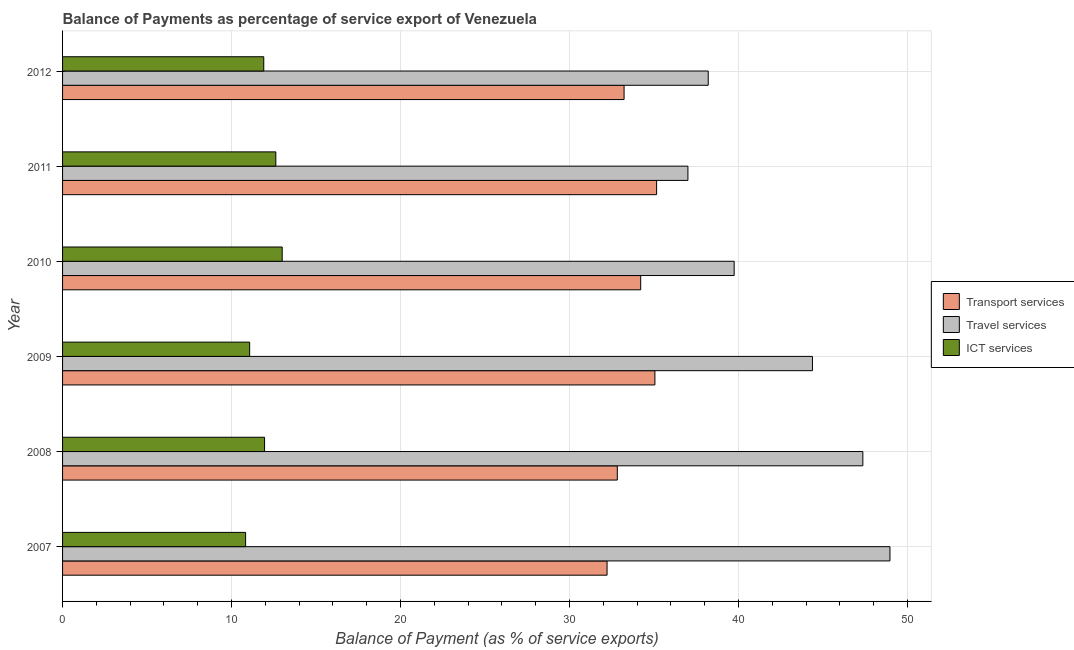How many different coloured bars are there?
Provide a succinct answer. 3. How many groups of bars are there?
Provide a short and direct response. 6. How many bars are there on the 3rd tick from the top?
Ensure brevity in your answer.  3. What is the balance of payment of transport services in 2010?
Provide a succinct answer. 34.21. Across all years, what is the maximum balance of payment of transport services?
Give a very brief answer. 35.15. Across all years, what is the minimum balance of payment of travel services?
Keep it short and to the point. 37.01. In which year was the balance of payment of ict services maximum?
Offer a terse response. 2010. In which year was the balance of payment of ict services minimum?
Ensure brevity in your answer.  2007. What is the total balance of payment of ict services in the graph?
Your answer should be compact. 71.38. What is the difference between the balance of payment of travel services in 2009 and that in 2010?
Ensure brevity in your answer.  4.63. What is the difference between the balance of payment of transport services in 2011 and the balance of payment of ict services in 2012?
Provide a succinct answer. 23.25. What is the average balance of payment of transport services per year?
Make the answer very short. 33.78. In the year 2011, what is the difference between the balance of payment of travel services and balance of payment of ict services?
Provide a succinct answer. 24.39. In how many years, is the balance of payment of transport services greater than 42 %?
Ensure brevity in your answer.  0. What is the ratio of the balance of payment of ict services in 2010 to that in 2012?
Offer a very short reply. 1.09. Is the balance of payment of transport services in 2008 less than that in 2012?
Ensure brevity in your answer.  Yes. What is the difference between the highest and the second highest balance of payment of transport services?
Make the answer very short. 0.1. What is the difference between the highest and the lowest balance of payment of travel services?
Your answer should be compact. 11.96. What does the 2nd bar from the top in 2009 represents?
Provide a short and direct response. Travel services. What does the 2nd bar from the bottom in 2012 represents?
Give a very brief answer. Travel services. Is it the case that in every year, the sum of the balance of payment of transport services and balance of payment of travel services is greater than the balance of payment of ict services?
Your answer should be very brief. Yes. How many bars are there?
Your answer should be very brief. 18. How many years are there in the graph?
Your answer should be compact. 6. What is the difference between two consecutive major ticks on the X-axis?
Ensure brevity in your answer.  10. Are the values on the major ticks of X-axis written in scientific E-notation?
Provide a short and direct response. No. Does the graph contain any zero values?
Offer a very short reply. No. Does the graph contain grids?
Offer a very short reply. Yes. Where does the legend appear in the graph?
Your response must be concise. Center right. How many legend labels are there?
Keep it short and to the point. 3. What is the title of the graph?
Make the answer very short. Balance of Payments as percentage of service export of Venezuela. What is the label or title of the X-axis?
Offer a terse response. Balance of Payment (as % of service exports). What is the label or title of the Y-axis?
Your response must be concise. Year. What is the Balance of Payment (as % of service exports) in Transport services in 2007?
Make the answer very short. 32.22. What is the Balance of Payment (as % of service exports) of Travel services in 2007?
Keep it short and to the point. 48.96. What is the Balance of Payment (as % of service exports) in ICT services in 2007?
Your answer should be compact. 10.83. What is the Balance of Payment (as % of service exports) of Transport services in 2008?
Your response must be concise. 32.83. What is the Balance of Payment (as % of service exports) of Travel services in 2008?
Provide a succinct answer. 47.36. What is the Balance of Payment (as % of service exports) of ICT services in 2008?
Offer a very short reply. 11.95. What is the Balance of Payment (as % of service exports) in Transport services in 2009?
Offer a terse response. 35.05. What is the Balance of Payment (as % of service exports) of Travel services in 2009?
Your answer should be compact. 44.37. What is the Balance of Payment (as % of service exports) of ICT services in 2009?
Make the answer very short. 11.07. What is the Balance of Payment (as % of service exports) in Transport services in 2010?
Provide a succinct answer. 34.21. What is the Balance of Payment (as % of service exports) in Travel services in 2010?
Offer a terse response. 39.74. What is the Balance of Payment (as % of service exports) of ICT services in 2010?
Provide a succinct answer. 13. What is the Balance of Payment (as % of service exports) in Transport services in 2011?
Ensure brevity in your answer.  35.15. What is the Balance of Payment (as % of service exports) in Travel services in 2011?
Offer a terse response. 37.01. What is the Balance of Payment (as % of service exports) in ICT services in 2011?
Your answer should be compact. 12.62. What is the Balance of Payment (as % of service exports) in Transport services in 2012?
Provide a short and direct response. 33.23. What is the Balance of Payment (as % of service exports) of Travel services in 2012?
Offer a very short reply. 38.21. What is the Balance of Payment (as % of service exports) of ICT services in 2012?
Your answer should be very brief. 11.91. Across all years, what is the maximum Balance of Payment (as % of service exports) in Transport services?
Provide a succinct answer. 35.15. Across all years, what is the maximum Balance of Payment (as % of service exports) in Travel services?
Offer a very short reply. 48.96. Across all years, what is the maximum Balance of Payment (as % of service exports) of ICT services?
Offer a very short reply. 13. Across all years, what is the minimum Balance of Payment (as % of service exports) in Transport services?
Your answer should be very brief. 32.22. Across all years, what is the minimum Balance of Payment (as % of service exports) of Travel services?
Your response must be concise. 37.01. Across all years, what is the minimum Balance of Payment (as % of service exports) in ICT services?
Your answer should be compact. 10.83. What is the total Balance of Payment (as % of service exports) in Transport services in the graph?
Your answer should be compact. 202.69. What is the total Balance of Payment (as % of service exports) in Travel services in the graph?
Give a very brief answer. 255.65. What is the total Balance of Payment (as % of service exports) of ICT services in the graph?
Your answer should be compact. 71.38. What is the difference between the Balance of Payment (as % of service exports) in Transport services in 2007 and that in 2008?
Your answer should be compact. -0.61. What is the difference between the Balance of Payment (as % of service exports) of Travel services in 2007 and that in 2008?
Give a very brief answer. 1.6. What is the difference between the Balance of Payment (as % of service exports) in ICT services in 2007 and that in 2008?
Give a very brief answer. -1.12. What is the difference between the Balance of Payment (as % of service exports) of Transport services in 2007 and that in 2009?
Make the answer very short. -2.83. What is the difference between the Balance of Payment (as % of service exports) in Travel services in 2007 and that in 2009?
Provide a short and direct response. 4.59. What is the difference between the Balance of Payment (as % of service exports) of ICT services in 2007 and that in 2009?
Your response must be concise. -0.24. What is the difference between the Balance of Payment (as % of service exports) in Transport services in 2007 and that in 2010?
Offer a very short reply. -1.99. What is the difference between the Balance of Payment (as % of service exports) of Travel services in 2007 and that in 2010?
Your answer should be compact. 9.22. What is the difference between the Balance of Payment (as % of service exports) of ICT services in 2007 and that in 2010?
Your response must be concise. -2.17. What is the difference between the Balance of Payment (as % of service exports) of Transport services in 2007 and that in 2011?
Your response must be concise. -2.93. What is the difference between the Balance of Payment (as % of service exports) in Travel services in 2007 and that in 2011?
Ensure brevity in your answer.  11.96. What is the difference between the Balance of Payment (as % of service exports) of ICT services in 2007 and that in 2011?
Keep it short and to the point. -1.79. What is the difference between the Balance of Payment (as % of service exports) of Transport services in 2007 and that in 2012?
Offer a terse response. -1.01. What is the difference between the Balance of Payment (as % of service exports) of Travel services in 2007 and that in 2012?
Provide a short and direct response. 10.75. What is the difference between the Balance of Payment (as % of service exports) of ICT services in 2007 and that in 2012?
Your answer should be compact. -1.07. What is the difference between the Balance of Payment (as % of service exports) of Transport services in 2008 and that in 2009?
Offer a terse response. -2.22. What is the difference between the Balance of Payment (as % of service exports) of Travel services in 2008 and that in 2009?
Offer a terse response. 2.98. What is the difference between the Balance of Payment (as % of service exports) of ICT services in 2008 and that in 2009?
Your response must be concise. 0.88. What is the difference between the Balance of Payment (as % of service exports) of Transport services in 2008 and that in 2010?
Your response must be concise. -1.38. What is the difference between the Balance of Payment (as % of service exports) of Travel services in 2008 and that in 2010?
Provide a short and direct response. 7.61. What is the difference between the Balance of Payment (as % of service exports) of ICT services in 2008 and that in 2010?
Offer a very short reply. -1.04. What is the difference between the Balance of Payment (as % of service exports) of Transport services in 2008 and that in 2011?
Provide a succinct answer. -2.33. What is the difference between the Balance of Payment (as % of service exports) of Travel services in 2008 and that in 2011?
Make the answer very short. 10.35. What is the difference between the Balance of Payment (as % of service exports) of ICT services in 2008 and that in 2011?
Give a very brief answer. -0.66. What is the difference between the Balance of Payment (as % of service exports) in Transport services in 2008 and that in 2012?
Your response must be concise. -0.4. What is the difference between the Balance of Payment (as % of service exports) in Travel services in 2008 and that in 2012?
Provide a succinct answer. 9.15. What is the difference between the Balance of Payment (as % of service exports) of ICT services in 2008 and that in 2012?
Offer a terse response. 0.05. What is the difference between the Balance of Payment (as % of service exports) in Transport services in 2009 and that in 2010?
Your response must be concise. 0.84. What is the difference between the Balance of Payment (as % of service exports) in Travel services in 2009 and that in 2010?
Ensure brevity in your answer.  4.63. What is the difference between the Balance of Payment (as % of service exports) of ICT services in 2009 and that in 2010?
Offer a terse response. -1.93. What is the difference between the Balance of Payment (as % of service exports) in Transport services in 2009 and that in 2011?
Keep it short and to the point. -0.1. What is the difference between the Balance of Payment (as % of service exports) of Travel services in 2009 and that in 2011?
Give a very brief answer. 7.37. What is the difference between the Balance of Payment (as % of service exports) of ICT services in 2009 and that in 2011?
Keep it short and to the point. -1.55. What is the difference between the Balance of Payment (as % of service exports) in Transport services in 2009 and that in 2012?
Make the answer very short. 1.82. What is the difference between the Balance of Payment (as % of service exports) in Travel services in 2009 and that in 2012?
Make the answer very short. 6.17. What is the difference between the Balance of Payment (as % of service exports) in ICT services in 2009 and that in 2012?
Ensure brevity in your answer.  -0.83. What is the difference between the Balance of Payment (as % of service exports) of Transport services in 2010 and that in 2011?
Your answer should be compact. -0.94. What is the difference between the Balance of Payment (as % of service exports) of Travel services in 2010 and that in 2011?
Keep it short and to the point. 2.74. What is the difference between the Balance of Payment (as % of service exports) in ICT services in 2010 and that in 2011?
Your response must be concise. 0.38. What is the difference between the Balance of Payment (as % of service exports) in Transport services in 2010 and that in 2012?
Give a very brief answer. 0.98. What is the difference between the Balance of Payment (as % of service exports) of Travel services in 2010 and that in 2012?
Offer a very short reply. 1.53. What is the difference between the Balance of Payment (as % of service exports) in Transport services in 2011 and that in 2012?
Ensure brevity in your answer.  1.93. What is the difference between the Balance of Payment (as % of service exports) in Travel services in 2011 and that in 2012?
Make the answer very short. -1.2. What is the difference between the Balance of Payment (as % of service exports) of ICT services in 2011 and that in 2012?
Offer a terse response. 0.71. What is the difference between the Balance of Payment (as % of service exports) in Transport services in 2007 and the Balance of Payment (as % of service exports) in Travel services in 2008?
Offer a very short reply. -15.14. What is the difference between the Balance of Payment (as % of service exports) of Transport services in 2007 and the Balance of Payment (as % of service exports) of ICT services in 2008?
Give a very brief answer. 20.27. What is the difference between the Balance of Payment (as % of service exports) of Travel services in 2007 and the Balance of Payment (as % of service exports) of ICT services in 2008?
Your response must be concise. 37.01. What is the difference between the Balance of Payment (as % of service exports) in Transport services in 2007 and the Balance of Payment (as % of service exports) in Travel services in 2009?
Keep it short and to the point. -12.15. What is the difference between the Balance of Payment (as % of service exports) in Transport services in 2007 and the Balance of Payment (as % of service exports) in ICT services in 2009?
Ensure brevity in your answer.  21.15. What is the difference between the Balance of Payment (as % of service exports) in Travel services in 2007 and the Balance of Payment (as % of service exports) in ICT services in 2009?
Your response must be concise. 37.89. What is the difference between the Balance of Payment (as % of service exports) in Transport services in 2007 and the Balance of Payment (as % of service exports) in Travel services in 2010?
Provide a short and direct response. -7.52. What is the difference between the Balance of Payment (as % of service exports) in Transport services in 2007 and the Balance of Payment (as % of service exports) in ICT services in 2010?
Offer a very short reply. 19.22. What is the difference between the Balance of Payment (as % of service exports) in Travel services in 2007 and the Balance of Payment (as % of service exports) in ICT services in 2010?
Your answer should be very brief. 35.96. What is the difference between the Balance of Payment (as % of service exports) of Transport services in 2007 and the Balance of Payment (as % of service exports) of Travel services in 2011?
Your answer should be very brief. -4.78. What is the difference between the Balance of Payment (as % of service exports) in Transport services in 2007 and the Balance of Payment (as % of service exports) in ICT services in 2011?
Ensure brevity in your answer.  19.6. What is the difference between the Balance of Payment (as % of service exports) of Travel services in 2007 and the Balance of Payment (as % of service exports) of ICT services in 2011?
Your answer should be very brief. 36.34. What is the difference between the Balance of Payment (as % of service exports) in Transport services in 2007 and the Balance of Payment (as % of service exports) in Travel services in 2012?
Provide a succinct answer. -5.99. What is the difference between the Balance of Payment (as % of service exports) of Transport services in 2007 and the Balance of Payment (as % of service exports) of ICT services in 2012?
Make the answer very short. 20.32. What is the difference between the Balance of Payment (as % of service exports) of Travel services in 2007 and the Balance of Payment (as % of service exports) of ICT services in 2012?
Ensure brevity in your answer.  37.05. What is the difference between the Balance of Payment (as % of service exports) in Transport services in 2008 and the Balance of Payment (as % of service exports) in Travel services in 2009?
Offer a very short reply. -11.55. What is the difference between the Balance of Payment (as % of service exports) of Transport services in 2008 and the Balance of Payment (as % of service exports) of ICT services in 2009?
Your answer should be very brief. 21.76. What is the difference between the Balance of Payment (as % of service exports) of Travel services in 2008 and the Balance of Payment (as % of service exports) of ICT services in 2009?
Ensure brevity in your answer.  36.29. What is the difference between the Balance of Payment (as % of service exports) of Transport services in 2008 and the Balance of Payment (as % of service exports) of Travel services in 2010?
Ensure brevity in your answer.  -6.91. What is the difference between the Balance of Payment (as % of service exports) of Transport services in 2008 and the Balance of Payment (as % of service exports) of ICT services in 2010?
Your answer should be very brief. 19.83. What is the difference between the Balance of Payment (as % of service exports) in Travel services in 2008 and the Balance of Payment (as % of service exports) in ICT services in 2010?
Your response must be concise. 34.36. What is the difference between the Balance of Payment (as % of service exports) in Transport services in 2008 and the Balance of Payment (as % of service exports) in Travel services in 2011?
Offer a very short reply. -4.18. What is the difference between the Balance of Payment (as % of service exports) of Transport services in 2008 and the Balance of Payment (as % of service exports) of ICT services in 2011?
Make the answer very short. 20.21. What is the difference between the Balance of Payment (as % of service exports) in Travel services in 2008 and the Balance of Payment (as % of service exports) in ICT services in 2011?
Offer a very short reply. 34.74. What is the difference between the Balance of Payment (as % of service exports) of Transport services in 2008 and the Balance of Payment (as % of service exports) of Travel services in 2012?
Give a very brief answer. -5.38. What is the difference between the Balance of Payment (as % of service exports) in Transport services in 2008 and the Balance of Payment (as % of service exports) in ICT services in 2012?
Your answer should be very brief. 20.92. What is the difference between the Balance of Payment (as % of service exports) in Travel services in 2008 and the Balance of Payment (as % of service exports) in ICT services in 2012?
Offer a terse response. 35.45. What is the difference between the Balance of Payment (as % of service exports) in Transport services in 2009 and the Balance of Payment (as % of service exports) in Travel services in 2010?
Keep it short and to the point. -4.69. What is the difference between the Balance of Payment (as % of service exports) in Transport services in 2009 and the Balance of Payment (as % of service exports) in ICT services in 2010?
Offer a terse response. 22.05. What is the difference between the Balance of Payment (as % of service exports) in Travel services in 2009 and the Balance of Payment (as % of service exports) in ICT services in 2010?
Your answer should be compact. 31.38. What is the difference between the Balance of Payment (as % of service exports) in Transport services in 2009 and the Balance of Payment (as % of service exports) in Travel services in 2011?
Your response must be concise. -1.95. What is the difference between the Balance of Payment (as % of service exports) of Transport services in 2009 and the Balance of Payment (as % of service exports) of ICT services in 2011?
Your response must be concise. 22.43. What is the difference between the Balance of Payment (as % of service exports) of Travel services in 2009 and the Balance of Payment (as % of service exports) of ICT services in 2011?
Ensure brevity in your answer.  31.76. What is the difference between the Balance of Payment (as % of service exports) of Transport services in 2009 and the Balance of Payment (as % of service exports) of Travel services in 2012?
Your answer should be very brief. -3.16. What is the difference between the Balance of Payment (as % of service exports) in Transport services in 2009 and the Balance of Payment (as % of service exports) in ICT services in 2012?
Your answer should be compact. 23.15. What is the difference between the Balance of Payment (as % of service exports) of Travel services in 2009 and the Balance of Payment (as % of service exports) of ICT services in 2012?
Your answer should be very brief. 32.47. What is the difference between the Balance of Payment (as % of service exports) of Transport services in 2010 and the Balance of Payment (as % of service exports) of Travel services in 2011?
Keep it short and to the point. -2.79. What is the difference between the Balance of Payment (as % of service exports) of Transport services in 2010 and the Balance of Payment (as % of service exports) of ICT services in 2011?
Your response must be concise. 21.59. What is the difference between the Balance of Payment (as % of service exports) in Travel services in 2010 and the Balance of Payment (as % of service exports) in ICT services in 2011?
Your answer should be compact. 27.12. What is the difference between the Balance of Payment (as % of service exports) of Transport services in 2010 and the Balance of Payment (as % of service exports) of Travel services in 2012?
Offer a very short reply. -4. What is the difference between the Balance of Payment (as % of service exports) of Transport services in 2010 and the Balance of Payment (as % of service exports) of ICT services in 2012?
Make the answer very short. 22.3. What is the difference between the Balance of Payment (as % of service exports) of Travel services in 2010 and the Balance of Payment (as % of service exports) of ICT services in 2012?
Your response must be concise. 27.84. What is the difference between the Balance of Payment (as % of service exports) of Transport services in 2011 and the Balance of Payment (as % of service exports) of Travel services in 2012?
Your answer should be very brief. -3.05. What is the difference between the Balance of Payment (as % of service exports) in Transport services in 2011 and the Balance of Payment (as % of service exports) in ICT services in 2012?
Give a very brief answer. 23.25. What is the difference between the Balance of Payment (as % of service exports) of Travel services in 2011 and the Balance of Payment (as % of service exports) of ICT services in 2012?
Your answer should be very brief. 25.1. What is the average Balance of Payment (as % of service exports) in Transport services per year?
Keep it short and to the point. 33.78. What is the average Balance of Payment (as % of service exports) of Travel services per year?
Provide a succinct answer. 42.61. What is the average Balance of Payment (as % of service exports) in ICT services per year?
Your answer should be compact. 11.9. In the year 2007, what is the difference between the Balance of Payment (as % of service exports) of Transport services and Balance of Payment (as % of service exports) of Travel services?
Provide a short and direct response. -16.74. In the year 2007, what is the difference between the Balance of Payment (as % of service exports) in Transport services and Balance of Payment (as % of service exports) in ICT services?
Provide a succinct answer. 21.39. In the year 2007, what is the difference between the Balance of Payment (as % of service exports) in Travel services and Balance of Payment (as % of service exports) in ICT services?
Give a very brief answer. 38.13. In the year 2008, what is the difference between the Balance of Payment (as % of service exports) of Transport services and Balance of Payment (as % of service exports) of Travel services?
Offer a terse response. -14.53. In the year 2008, what is the difference between the Balance of Payment (as % of service exports) in Transport services and Balance of Payment (as % of service exports) in ICT services?
Provide a succinct answer. 20.87. In the year 2008, what is the difference between the Balance of Payment (as % of service exports) of Travel services and Balance of Payment (as % of service exports) of ICT services?
Make the answer very short. 35.4. In the year 2009, what is the difference between the Balance of Payment (as % of service exports) of Transport services and Balance of Payment (as % of service exports) of Travel services?
Your response must be concise. -9.32. In the year 2009, what is the difference between the Balance of Payment (as % of service exports) in Transport services and Balance of Payment (as % of service exports) in ICT services?
Provide a short and direct response. 23.98. In the year 2009, what is the difference between the Balance of Payment (as % of service exports) of Travel services and Balance of Payment (as % of service exports) of ICT services?
Provide a succinct answer. 33.3. In the year 2010, what is the difference between the Balance of Payment (as % of service exports) of Transport services and Balance of Payment (as % of service exports) of Travel services?
Provide a succinct answer. -5.53. In the year 2010, what is the difference between the Balance of Payment (as % of service exports) of Transport services and Balance of Payment (as % of service exports) of ICT services?
Offer a terse response. 21.21. In the year 2010, what is the difference between the Balance of Payment (as % of service exports) in Travel services and Balance of Payment (as % of service exports) in ICT services?
Keep it short and to the point. 26.75. In the year 2011, what is the difference between the Balance of Payment (as % of service exports) of Transport services and Balance of Payment (as % of service exports) of Travel services?
Give a very brief answer. -1.85. In the year 2011, what is the difference between the Balance of Payment (as % of service exports) in Transport services and Balance of Payment (as % of service exports) in ICT services?
Provide a short and direct response. 22.53. In the year 2011, what is the difference between the Balance of Payment (as % of service exports) of Travel services and Balance of Payment (as % of service exports) of ICT services?
Your answer should be very brief. 24.39. In the year 2012, what is the difference between the Balance of Payment (as % of service exports) of Transport services and Balance of Payment (as % of service exports) of Travel services?
Your response must be concise. -4.98. In the year 2012, what is the difference between the Balance of Payment (as % of service exports) in Transport services and Balance of Payment (as % of service exports) in ICT services?
Your response must be concise. 21.32. In the year 2012, what is the difference between the Balance of Payment (as % of service exports) in Travel services and Balance of Payment (as % of service exports) in ICT services?
Provide a short and direct response. 26.3. What is the ratio of the Balance of Payment (as % of service exports) in Transport services in 2007 to that in 2008?
Ensure brevity in your answer.  0.98. What is the ratio of the Balance of Payment (as % of service exports) in Travel services in 2007 to that in 2008?
Offer a terse response. 1.03. What is the ratio of the Balance of Payment (as % of service exports) of ICT services in 2007 to that in 2008?
Provide a succinct answer. 0.91. What is the ratio of the Balance of Payment (as % of service exports) in Transport services in 2007 to that in 2009?
Keep it short and to the point. 0.92. What is the ratio of the Balance of Payment (as % of service exports) in Travel services in 2007 to that in 2009?
Offer a very short reply. 1.1. What is the ratio of the Balance of Payment (as % of service exports) in ICT services in 2007 to that in 2009?
Your answer should be very brief. 0.98. What is the ratio of the Balance of Payment (as % of service exports) of Transport services in 2007 to that in 2010?
Offer a terse response. 0.94. What is the ratio of the Balance of Payment (as % of service exports) in Travel services in 2007 to that in 2010?
Your response must be concise. 1.23. What is the ratio of the Balance of Payment (as % of service exports) of ICT services in 2007 to that in 2010?
Ensure brevity in your answer.  0.83. What is the ratio of the Balance of Payment (as % of service exports) in Transport services in 2007 to that in 2011?
Offer a very short reply. 0.92. What is the ratio of the Balance of Payment (as % of service exports) of Travel services in 2007 to that in 2011?
Offer a terse response. 1.32. What is the ratio of the Balance of Payment (as % of service exports) in ICT services in 2007 to that in 2011?
Keep it short and to the point. 0.86. What is the ratio of the Balance of Payment (as % of service exports) of Transport services in 2007 to that in 2012?
Ensure brevity in your answer.  0.97. What is the ratio of the Balance of Payment (as % of service exports) of Travel services in 2007 to that in 2012?
Make the answer very short. 1.28. What is the ratio of the Balance of Payment (as % of service exports) of ICT services in 2007 to that in 2012?
Provide a succinct answer. 0.91. What is the ratio of the Balance of Payment (as % of service exports) in Transport services in 2008 to that in 2009?
Provide a short and direct response. 0.94. What is the ratio of the Balance of Payment (as % of service exports) of Travel services in 2008 to that in 2009?
Your response must be concise. 1.07. What is the ratio of the Balance of Payment (as % of service exports) of ICT services in 2008 to that in 2009?
Your answer should be compact. 1.08. What is the ratio of the Balance of Payment (as % of service exports) of Transport services in 2008 to that in 2010?
Make the answer very short. 0.96. What is the ratio of the Balance of Payment (as % of service exports) in Travel services in 2008 to that in 2010?
Ensure brevity in your answer.  1.19. What is the ratio of the Balance of Payment (as % of service exports) in ICT services in 2008 to that in 2010?
Make the answer very short. 0.92. What is the ratio of the Balance of Payment (as % of service exports) of Transport services in 2008 to that in 2011?
Make the answer very short. 0.93. What is the ratio of the Balance of Payment (as % of service exports) of Travel services in 2008 to that in 2011?
Offer a very short reply. 1.28. What is the ratio of the Balance of Payment (as % of service exports) in ICT services in 2008 to that in 2011?
Provide a short and direct response. 0.95. What is the ratio of the Balance of Payment (as % of service exports) in Travel services in 2008 to that in 2012?
Provide a succinct answer. 1.24. What is the ratio of the Balance of Payment (as % of service exports) in Transport services in 2009 to that in 2010?
Your answer should be compact. 1.02. What is the ratio of the Balance of Payment (as % of service exports) in Travel services in 2009 to that in 2010?
Offer a very short reply. 1.12. What is the ratio of the Balance of Payment (as % of service exports) in ICT services in 2009 to that in 2010?
Keep it short and to the point. 0.85. What is the ratio of the Balance of Payment (as % of service exports) of Transport services in 2009 to that in 2011?
Keep it short and to the point. 1. What is the ratio of the Balance of Payment (as % of service exports) in Travel services in 2009 to that in 2011?
Offer a terse response. 1.2. What is the ratio of the Balance of Payment (as % of service exports) of ICT services in 2009 to that in 2011?
Ensure brevity in your answer.  0.88. What is the ratio of the Balance of Payment (as % of service exports) of Transport services in 2009 to that in 2012?
Provide a short and direct response. 1.05. What is the ratio of the Balance of Payment (as % of service exports) in Travel services in 2009 to that in 2012?
Your answer should be very brief. 1.16. What is the ratio of the Balance of Payment (as % of service exports) in ICT services in 2009 to that in 2012?
Give a very brief answer. 0.93. What is the ratio of the Balance of Payment (as % of service exports) in Transport services in 2010 to that in 2011?
Give a very brief answer. 0.97. What is the ratio of the Balance of Payment (as % of service exports) in Travel services in 2010 to that in 2011?
Offer a very short reply. 1.07. What is the ratio of the Balance of Payment (as % of service exports) of ICT services in 2010 to that in 2011?
Keep it short and to the point. 1.03. What is the ratio of the Balance of Payment (as % of service exports) of Transport services in 2010 to that in 2012?
Offer a terse response. 1.03. What is the ratio of the Balance of Payment (as % of service exports) of Travel services in 2010 to that in 2012?
Your answer should be very brief. 1.04. What is the ratio of the Balance of Payment (as % of service exports) in ICT services in 2010 to that in 2012?
Offer a very short reply. 1.09. What is the ratio of the Balance of Payment (as % of service exports) of Transport services in 2011 to that in 2012?
Make the answer very short. 1.06. What is the ratio of the Balance of Payment (as % of service exports) of Travel services in 2011 to that in 2012?
Your answer should be very brief. 0.97. What is the ratio of the Balance of Payment (as % of service exports) of ICT services in 2011 to that in 2012?
Make the answer very short. 1.06. What is the difference between the highest and the second highest Balance of Payment (as % of service exports) of Transport services?
Keep it short and to the point. 0.1. What is the difference between the highest and the second highest Balance of Payment (as % of service exports) of Travel services?
Provide a short and direct response. 1.6. What is the difference between the highest and the second highest Balance of Payment (as % of service exports) in ICT services?
Offer a terse response. 0.38. What is the difference between the highest and the lowest Balance of Payment (as % of service exports) of Transport services?
Your response must be concise. 2.93. What is the difference between the highest and the lowest Balance of Payment (as % of service exports) of Travel services?
Your response must be concise. 11.96. What is the difference between the highest and the lowest Balance of Payment (as % of service exports) in ICT services?
Your answer should be compact. 2.17. 